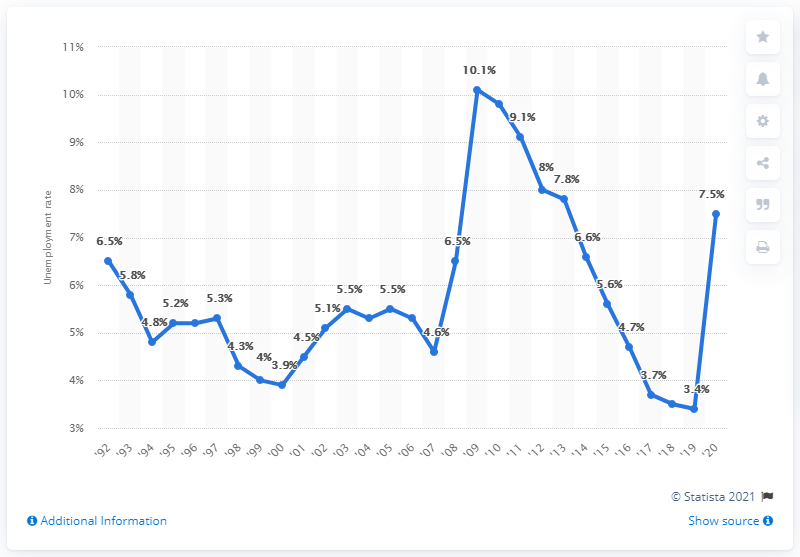List a handful of essential elements in this visual. The unemployment rate in Tennessee during 2009 was 3.4%. According to data from 2009, Tennessee's highest unemployment rate was 10.1%. 